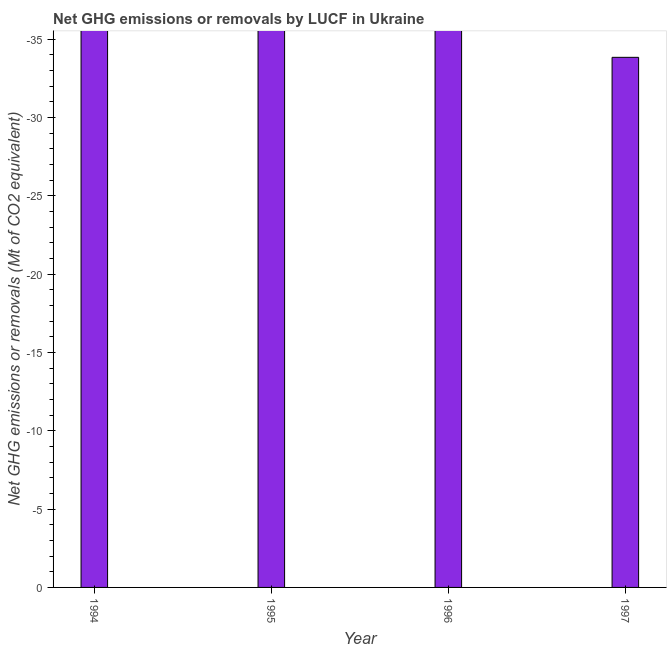Does the graph contain any zero values?
Your answer should be very brief. Yes. Does the graph contain grids?
Your answer should be compact. No. What is the title of the graph?
Provide a short and direct response. Net GHG emissions or removals by LUCF in Ukraine. What is the label or title of the Y-axis?
Provide a succinct answer. Net GHG emissions or removals (Mt of CO2 equivalent). What is the ghg net emissions or removals in 1995?
Your response must be concise. 0. What is the median ghg net emissions or removals?
Your response must be concise. 0. In how many years, is the ghg net emissions or removals greater than -17 Mt?
Your answer should be very brief. 0. In how many years, is the ghg net emissions or removals greater than the average ghg net emissions or removals taken over all years?
Ensure brevity in your answer.  0. How many bars are there?
Keep it short and to the point. 0. Are all the bars in the graph horizontal?
Your answer should be compact. No. Are the values on the major ticks of Y-axis written in scientific E-notation?
Your answer should be very brief. No. What is the Net GHG emissions or removals (Mt of CO2 equivalent) of 1994?
Keep it short and to the point. 0. What is the Net GHG emissions or removals (Mt of CO2 equivalent) in 1995?
Make the answer very short. 0. 